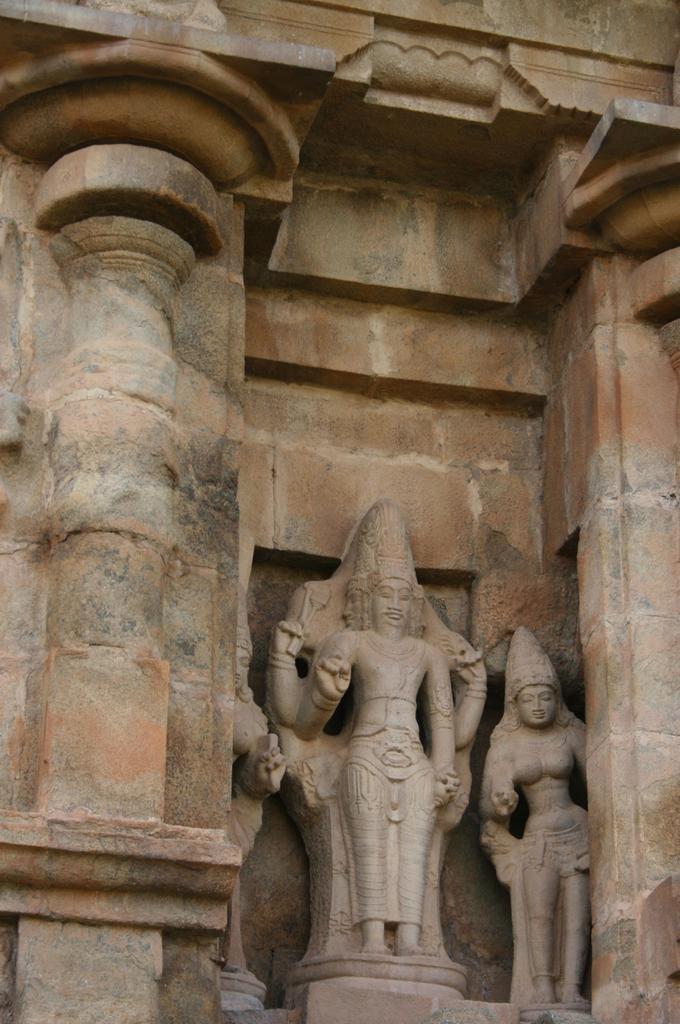In one or two sentences, can you explain what this image depicts? In this image we can see the statues and a wall. 